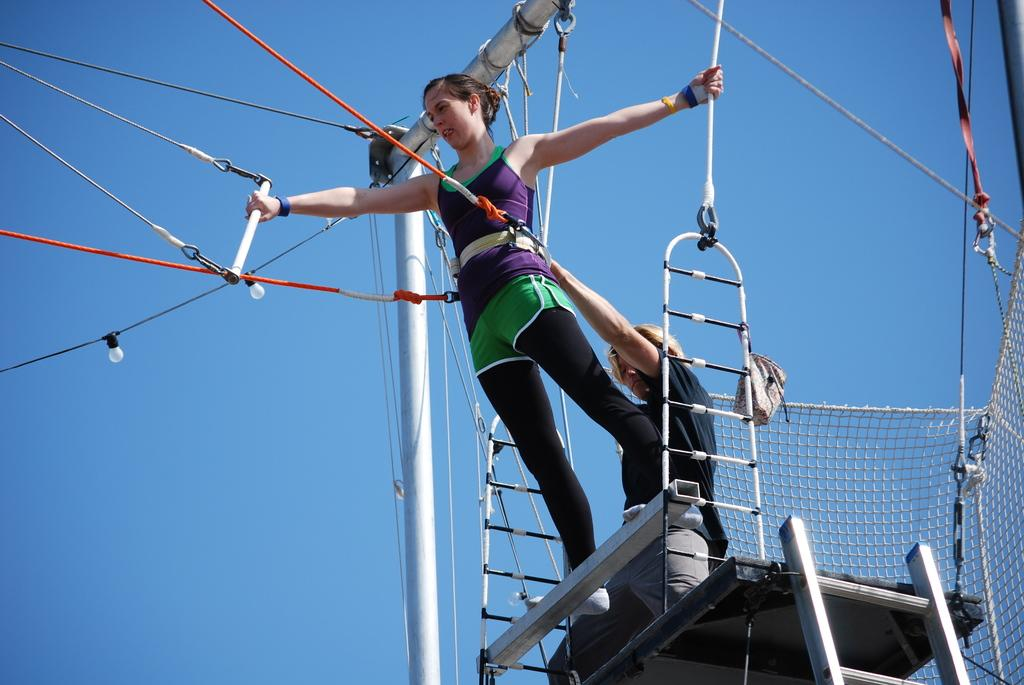How many people are present in the image? There are two people in the image. What objects can be seen in the image besides the people? There is a ladder, a net, a pole, and lights in the image. What is the color of the sky in the image? The sky is blue at the top of the image. What type of pie is being served to the people in the image? There is no pie present in the image; it features a ladder, a net, a pole, and lights. How does the plough affect the people in the image? There is no plough present in the image; it features a ladder, a net, a pole, and lights. 